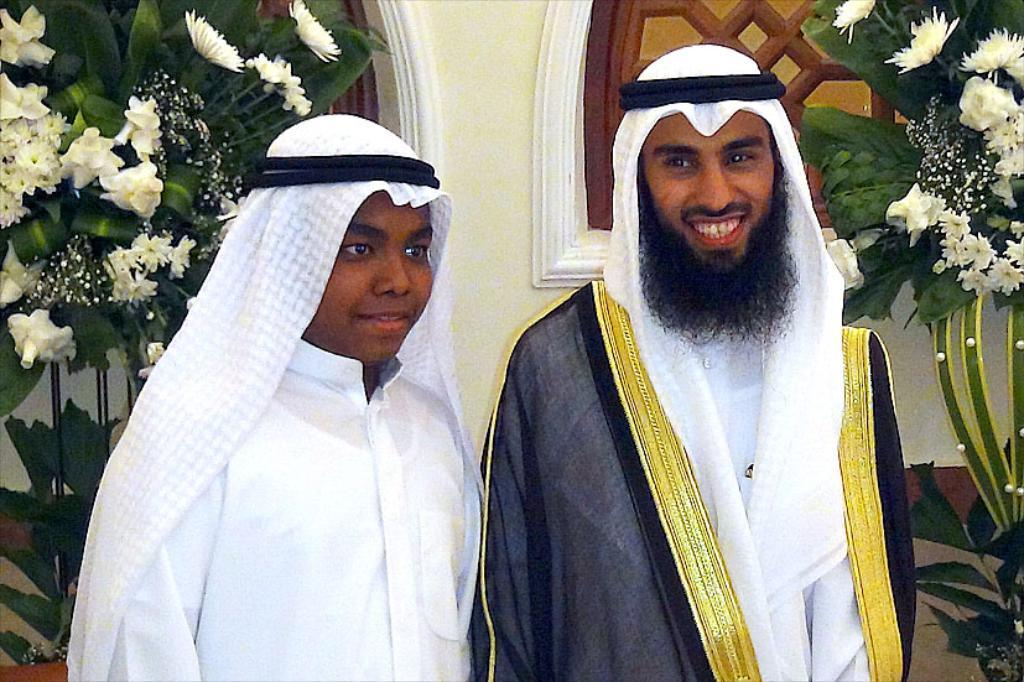How many people are in the image? There are two people standing in the image. What are the people wearing on their heads? The people are wearing turbans. What can be seen in the background of the image? There is a wall and windows visible in the background. What type of plants can be seen in the image? There are decorative plants in the image. What other objects are present in the image? Flowers are present in the image. What type of trouble is the quilt causing in the image? There is no quilt present in the image, so it cannot cause any trouble. How is the pail being used in the image? There is no pail present in the image, so it cannot be used for any purpose. 